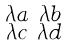Convert formula to latex. <formula><loc_0><loc_0><loc_500><loc_500>\begin{smallmatrix} \lambda a & \lambda b \\ \lambda c & \lambda d \end{smallmatrix}</formula> 